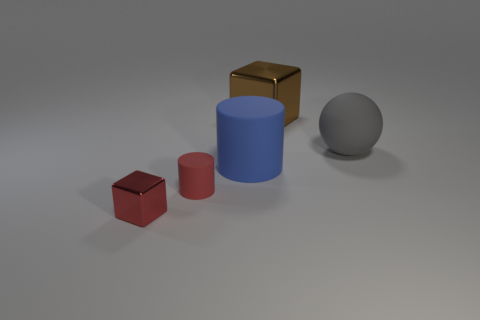Are there any balls of the same color as the large cylinder?
Your answer should be compact. No. There is a red thing that is made of the same material as the large gray sphere; what size is it?
Give a very brief answer. Small. Does the tiny matte object have the same color as the tiny metallic cube?
Offer a terse response. Yes. Is the shape of the matte object that is right of the brown cube the same as  the brown thing?
Provide a short and direct response. No. What number of metal cylinders have the same size as the brown cube?
Give a very brief answer. 0. There is a tiny metallic object that is the same color as the tiny matte cylinder; what is its shape?
Provide a succinct answer. Cube. Is there a red metallic thing that is behind the metallic block behind the small red shiny block?
Make the answer very short. No. How many things are red objects that are behind the small cube or big brown metallic things?
Make the answer very short. 2. What number of red metallic spheres are there?
Offer a very short reply. 0. The large brown object that is made of the same material as the tiny red cube is what shape?
Your answer should be compact. Cube. 